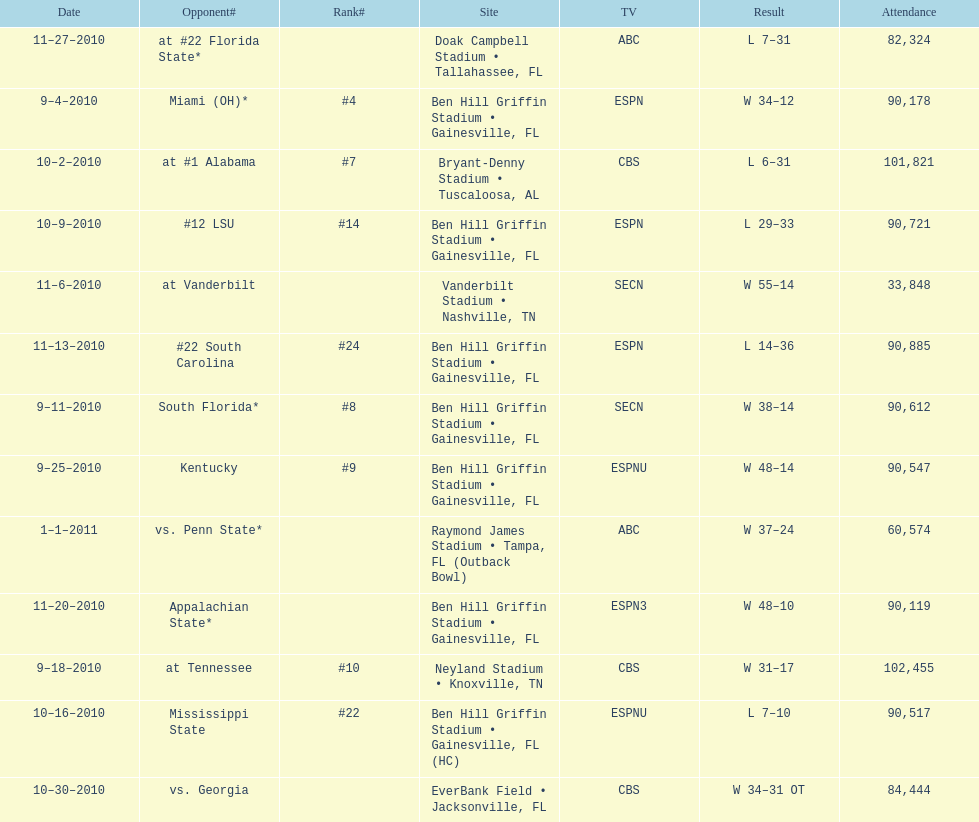What is the number of games won by the university of florida with a margin of at least 10 points? 7. 